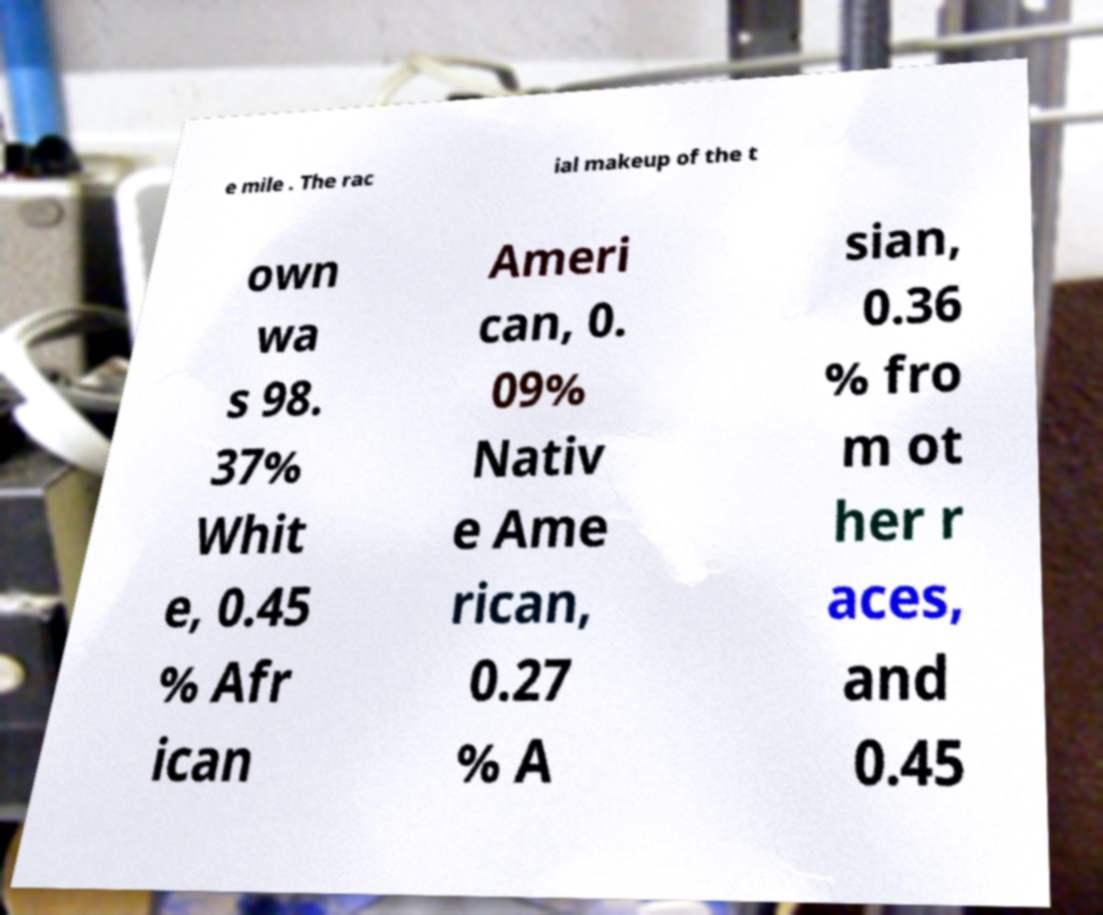I need the written content from this picture converted into text. Can you do that? e mile . The rac ial makeup of the t own wa s 98. 37% Whit e, 0.45 % Afr ican Ameri can, 0. 09% Nativ e Ame rican, 0.27 % A sian, 0.36 % fro m ot her r aces, and 0.45 